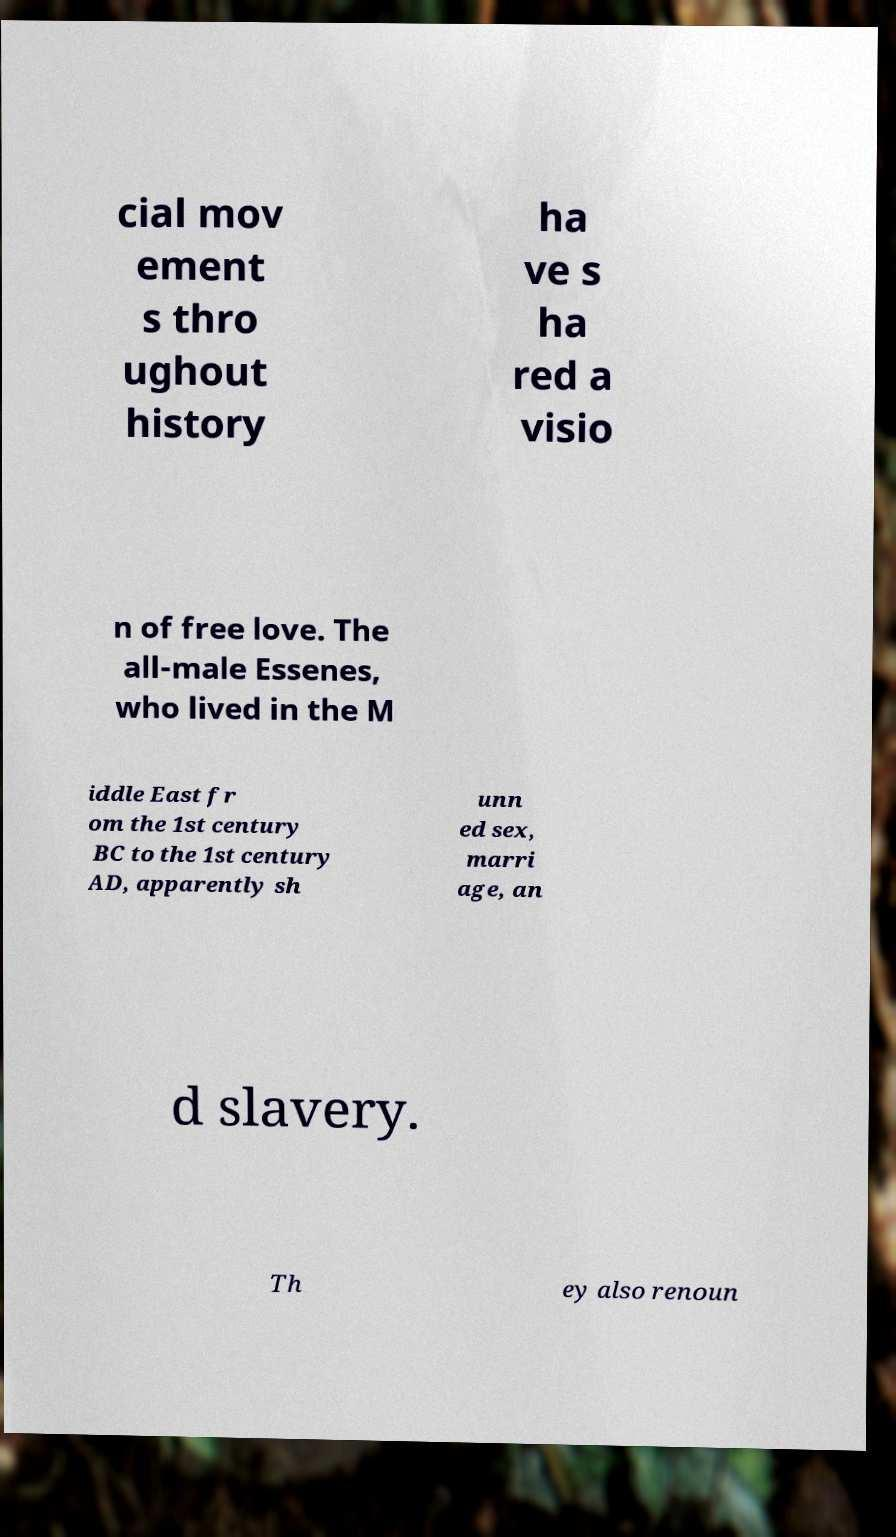Can you accurately transcribe the text from the provided image for me? cial mov ement s thro ughout history ha ve s ha red a visio n of free love. The all-male Essenes, who lived in the M iddle East fr om the 1st century BC to the 1st century AD, apparently sh unn ed sex, marri age, an d slavery. Th ey also renoun 